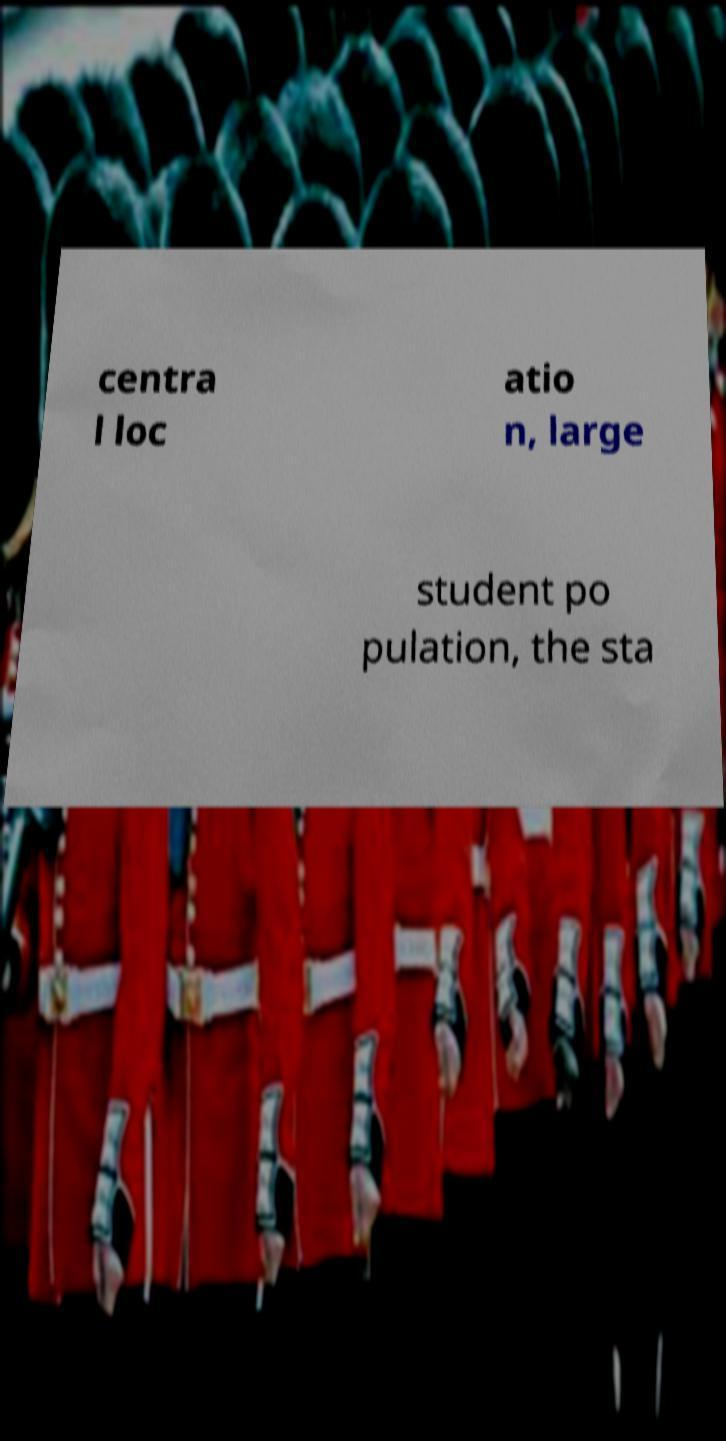I need the written content from this picture converted into text. Can you do that? centra l loc atio n, large student po pulation, the sta 